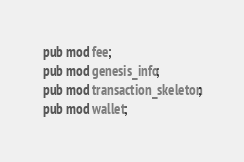<code> <loc_0><loc_0><loc_500><loc_500><_Rust_>pub mod fee;
pub mod genesis_info;
pub mod transaction_skeleton;
pub mod wallet;
</code> 